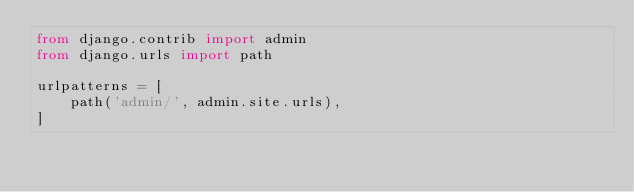<code> <loc_0><loc_0><loc_500><loc_500><_Python_>from django.contrib import admin
from django.urls import path

urlpatterns = [
    path('admin/', admin.site.urls),
]
</code> 